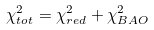<formula> <loc_0><loc_0><loc_500><loc_500>\chi ^ { 2 } _ { t o t } = \chi ^ { 2 } _ { r e d } + \chi ^ { 2 } _ { B A O }</formula> 